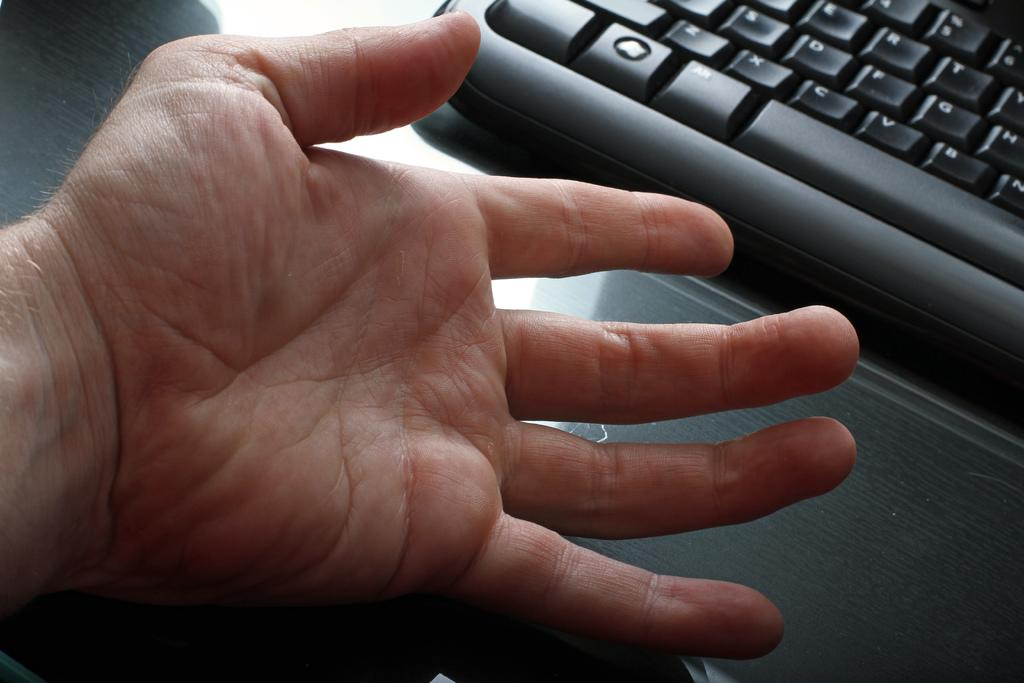Provide a one-sentence caption for the provided image. The Alt button of a keyboard can be seen in front of a hand. 